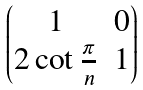Convert formula to latex. <formula><loc_0><loc_0><loc_500><loc_500>\begin{pmatrix} 1 & 0 \\ 2 \cot \frac { \pi } { n } & 1 \\ \end{pmatrix}</formula> 